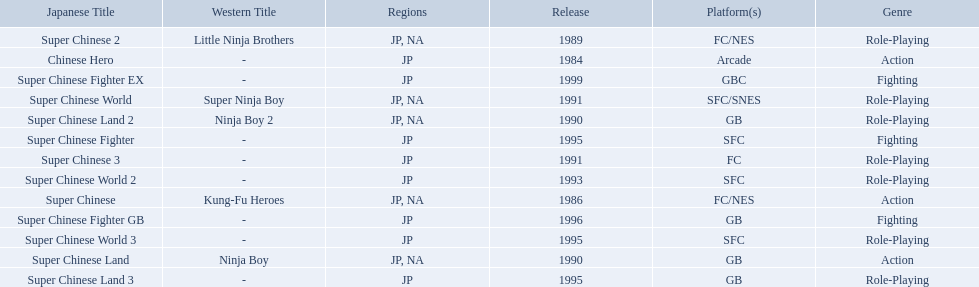Super ninja world was released in what countries? JP, NA. What was the original name for this title? Super Chinese World. What japanese titles were released in the north american (na) region? Super Chinese, Super Chinese 2, Super Chinese Land, Super Chinese Land 2, Super Chinese World. Of those, which one was released most recently? Super Chinese World. 